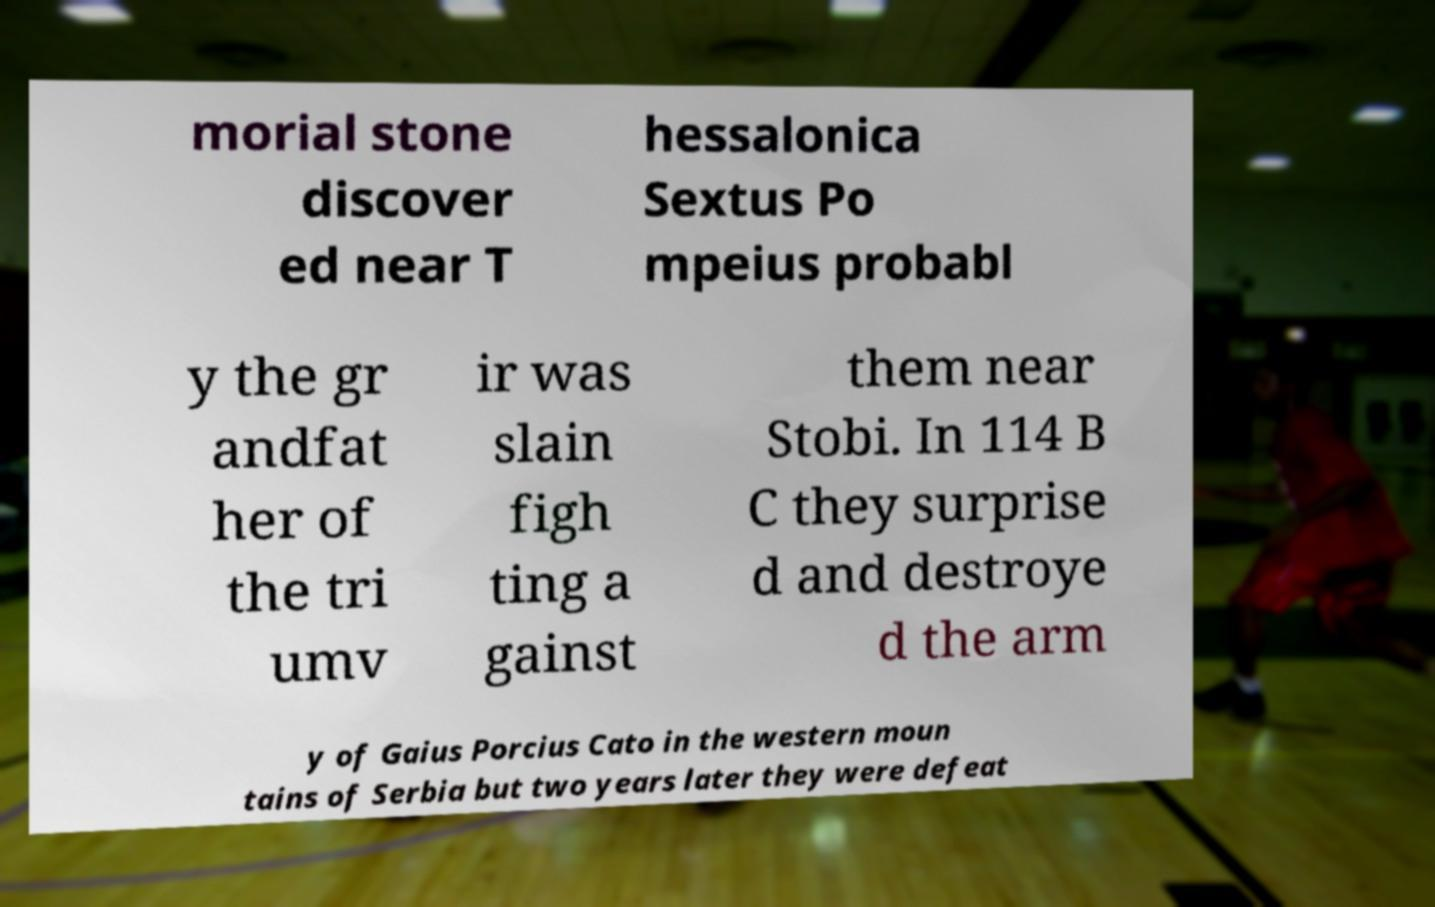There's text embedded in this image that I need extracted. Can you transcribe it verbatim? morial stone discover ed near T hessalonica Sextus Po mpeius probabl y the gr andfat her of the tri umv ir was slain figh ting a gainst them near Stobi. In 114 B C they surprise d and destroye d the arm y of Gaius Porcius Cato in the western moun tains of Serbia but two years later they were defeat 